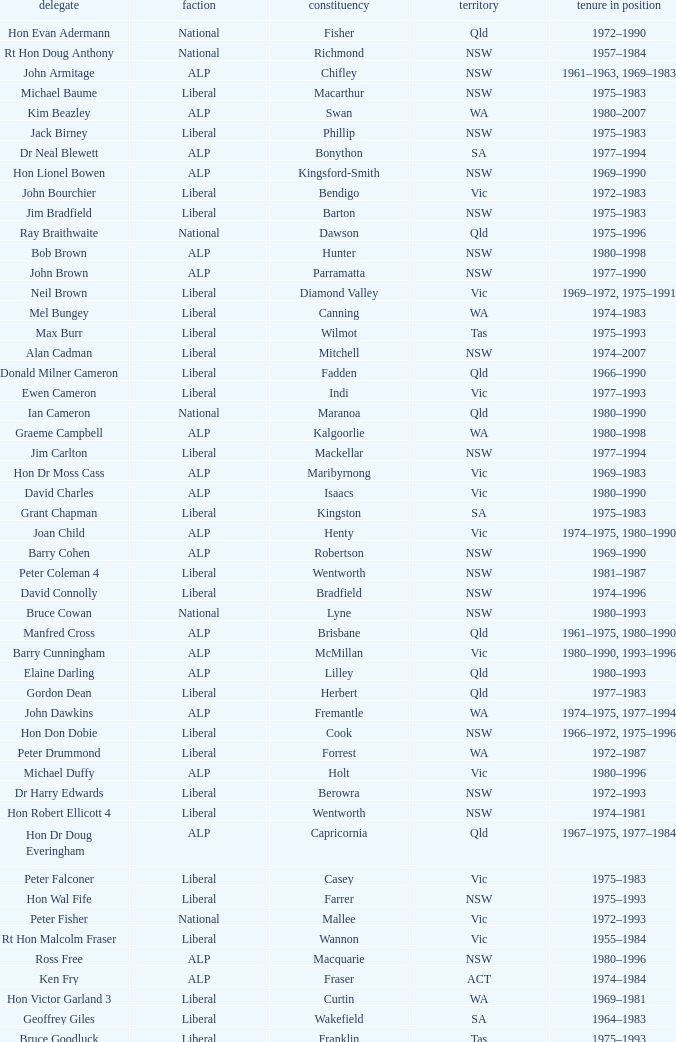Which party had a member from the state of Vic and an Electorate called Wannon? Liberal. 